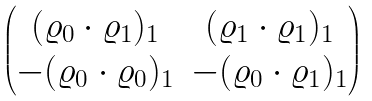<formula> <loc_0><loc_0><loc_500><loc_500>\begin{pmatrix} ( { \varrho } _ { 0 } \cdot { \varrho } _ { 1 } ) _ { 1 } & ( { \varrho } _ { 1 } \cdot { \varrho } _ { 1 } ) _ { 1 } \\ - ( { \varrho } _ { 0 } \cdot { \varrho } _ { 0 } ) _ { 1 } & - ( \varrho _ { 0 } \cdot \varrho _ { 1 } ) _ { 1 } \end{pmatrix}</formula> 